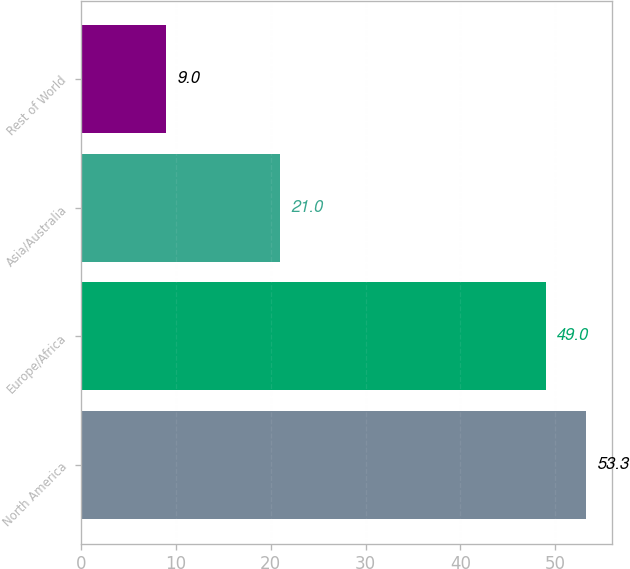<chart> <loc_0><loc_0><loc_500><loc_500><bar_chart><fcel>North America<fcel>Europe/Africa<fcel>Asia/Australia<fcel>Rest of World<nl><fcel>53.3<fcel>49<fcel>21<fcel>9<nl></chart> 